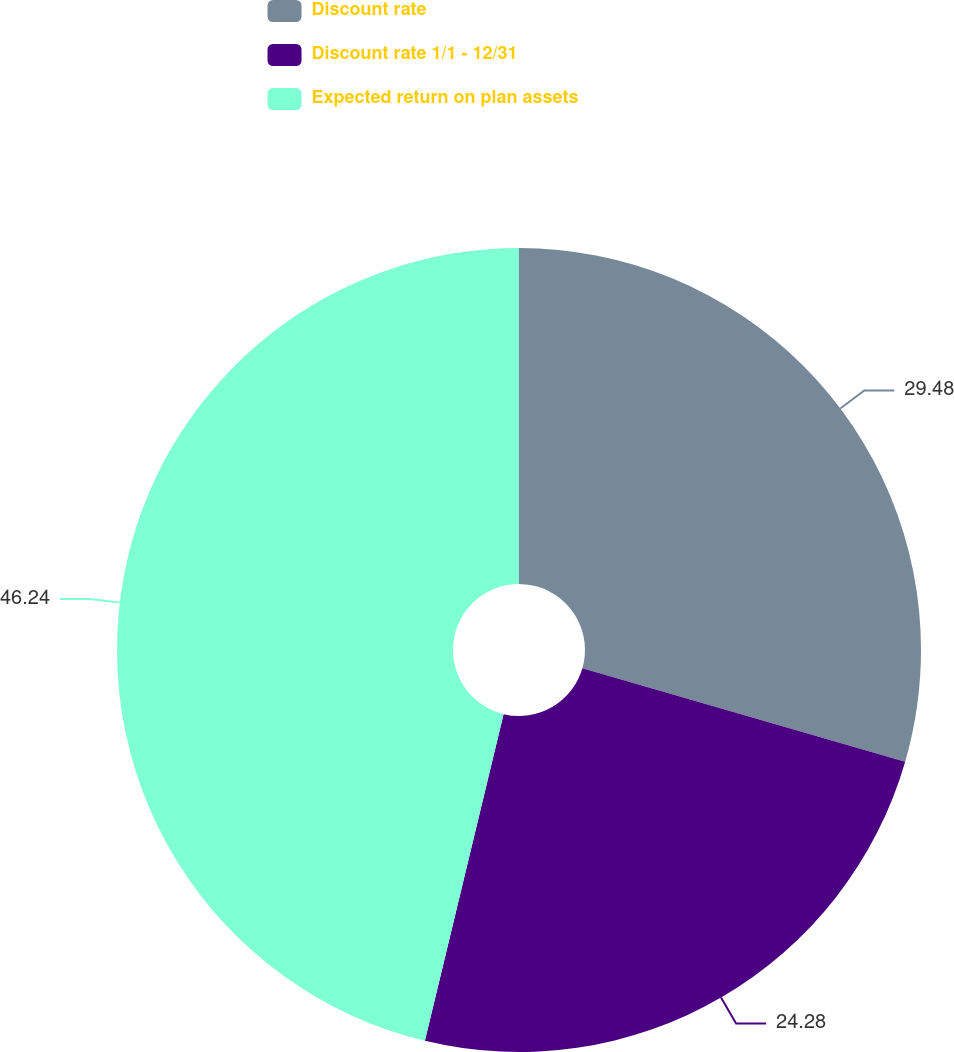Convert chart to OTSL. <chart><loc_0><loc_0><loc_500><loc_500><pie_chart><fcel>Discount rate<fcel>Discount rate 1/1 - 12/31<fcel>Expected return on plan assets<nl><fcel>29.48%<fcel>24.28%<fcel>46.24%<nl></chart> 